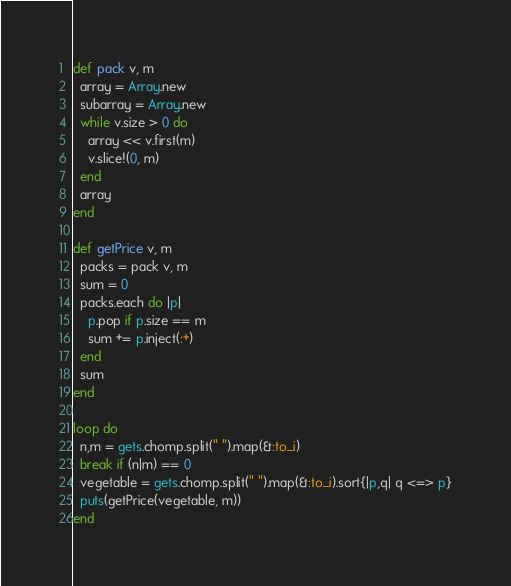<code> <loc_0><loc_0><loc_500><loc_500><_Ruby_>def pack v, m
  array = Array.new
  subarray = Array.new
  while v.size > 0 do
    array << v.first(m)
    v.slice!(0, m)
  end
  array
end

def getPrice v, m
  packs = pack v, m
  sum = 0
  packs.each do |p|
    p.pop if p.size == m
    sum += p.inject(:+)
  end
  sum
end

loop do
  n,m = gets.chomp.split(" ").map(&:to_i)
  break if (n|m) == 0
  vegetable = gets.chomp.split(" ").map(&:to_i).sort{|p,q| q <=> p}
  puts(getPrice(vegetable, m))
end</code> 